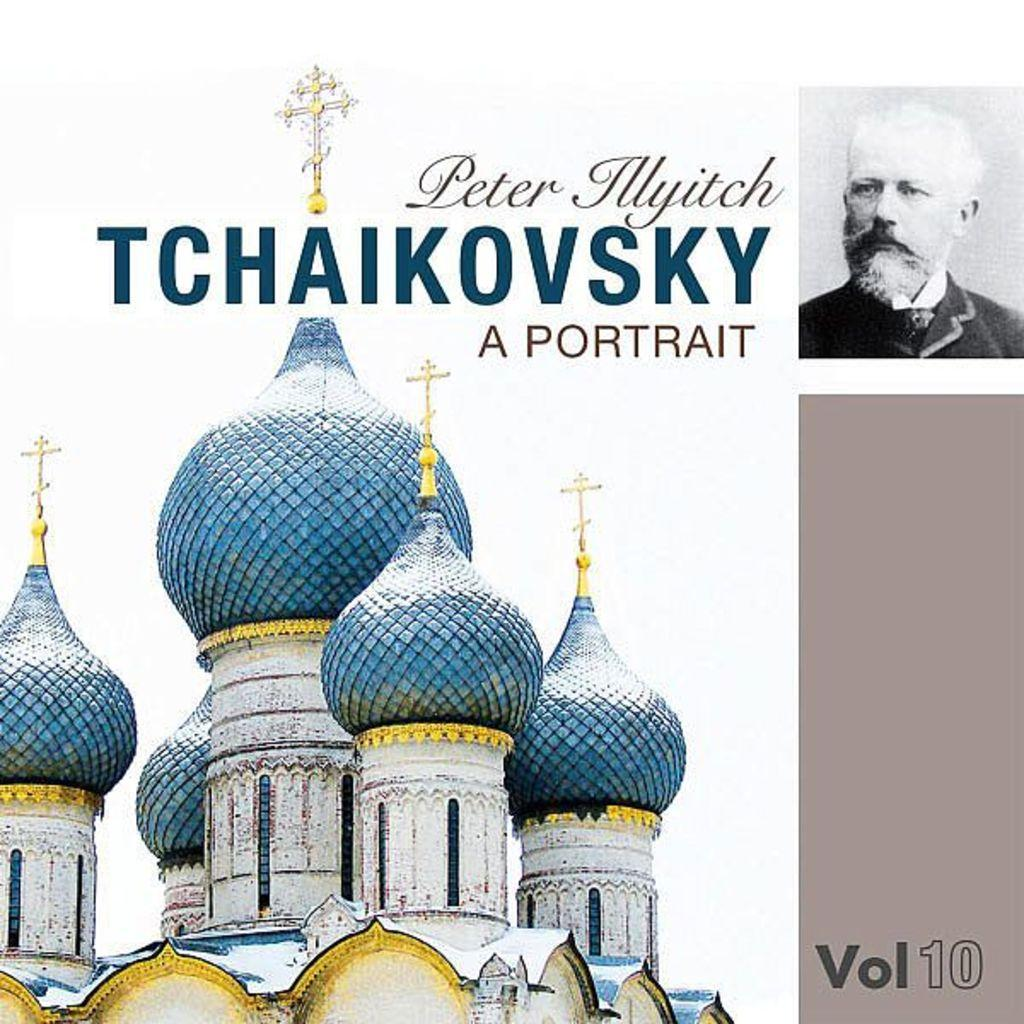What is featured on the poster in the image? The poster contains a building and a person. What else can be seen on the poster besides the building and person? There is text written on the poster. What type of poison is the person holding in the image? There is no poison present in the image; the person is not holding any such substance. How does the behavior of the person on the poster change throughout the day? The image is a static representation and does not depict any changes in the person's behavior over time. 